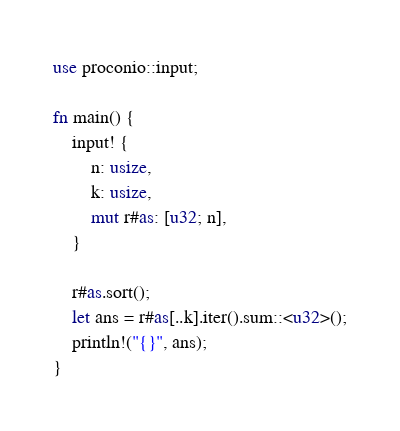<code> <loc_0><loc_0><loc_500><loc_500><_Rust_>use proconio::input;

fn main() {
    input! {
        n: usize,
        k: usize,
        mut r#as: [u32; n],
    }

    r#as.sort();
    let ans = r#as[..k].iter().sum::<u32>();
    println!("{}", ans);
}
</code> 